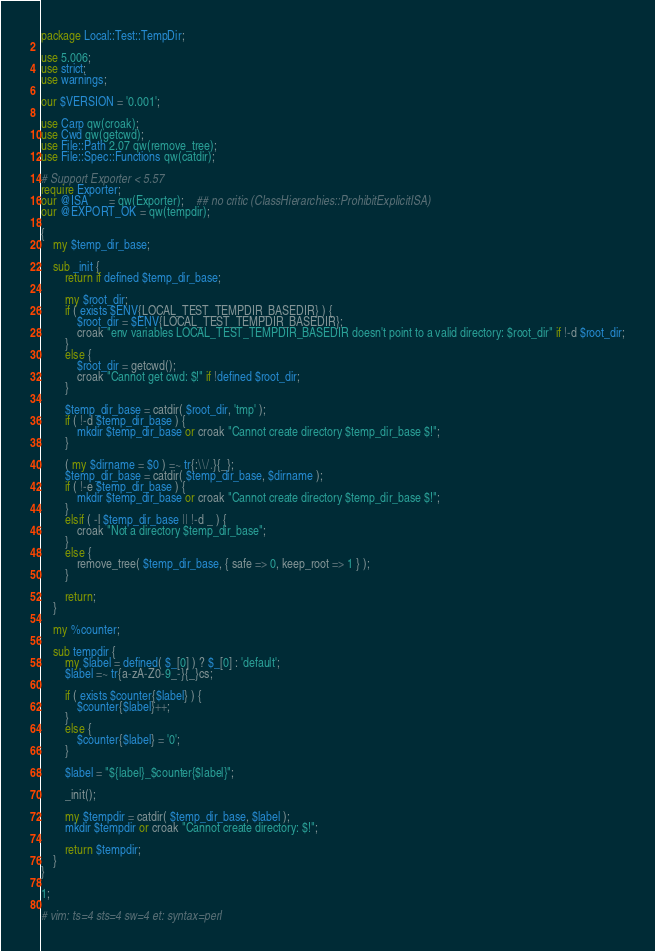<code> <loc_0><loc_0><loc_500><loc_500><_Perl_>package Local::Test::TempDir;

use 5.006;
use strict;
use warnings;

our $VERSION = '0.001';

use Carp qw(croak);
use Cwd qw(getcwd);
use File::Path 2.07 qw(remove_tree);
use File::Spec::Functions qw(catdir);

# Support Exporter < 5.57
require Exporter;
our @ISA       = qw(Exporter);    ## no critic (ClassHierarchies::ProhibitExplicitISA)
our @EXPORT_OK = qw(tempdir);

{
    my $temp_dir_base;

    sub _init {
        return if defined $temp_dir_base;

        my $root_dir;
        if ( exists $ENV{LOCAL_TEST_TEMPDIR_BASEDIR} ) {
            $root_dir = $ENV{LOCAL_TEST_TEMPDIR_BASEDIR};
            croak "env variables LOCAL_TEST_TEMPDIR_BASEDIR doesn't point to a valid directory: $root_dir" if !-d $root_dir;
        }
        else {
            $root_dir = getcwd();
            croak "Cannot get cwd: $!" if !defined $root_dir;
        }

        $temp_dir_base = catdir( $root_dir, 'tmp' );
        if ( !-d $temp_dir_base ) {
            mkdir $temp_dir_base or croak "Cannot create directory $temp_dir_base $!";
        }

        ( my $dirname = $0 ) =~ tr{:\\/.}{_};
        $temp_dir_base = catdir( $temp_dir_base, $dirname );
        if ( !-e $temp_dir_base ) {
            mkdir $temp_dir_base or croak "Cannot create directory $temp_dir_base $!";
        }
        elsif ( -l $temp_dir_base || !-d _ ) {
            croak "Not a directory $temp_dir_base";
        }
        else {
            remove_tree( $temp_dir_base, { safe => 0, keep_root => 1 } );
        }

        return;
    }

    my %counter;

    sub tempdir {
        my $label = defined( $_[0] ) ? $_[0] : 'default';
        $label =~ tr{a-zA-Z0-9_-}{_}cs;

        if ( exists $counter{$label} ) {
            $counter{$label}++;
        }
        else {
            $counter{$label} = '0';
        }

        $label = "${label}_$counter{$label}";

        _init();

        my $tempdir = catdir( $temp_dir_base, $label );
        mkdir $tempdir or croak "Cannot create directory: $!";

        return $tempdir;
    }
}

1;

# vim: ts=4 sts=4 sw=4 et: syntax=perl
</code> 